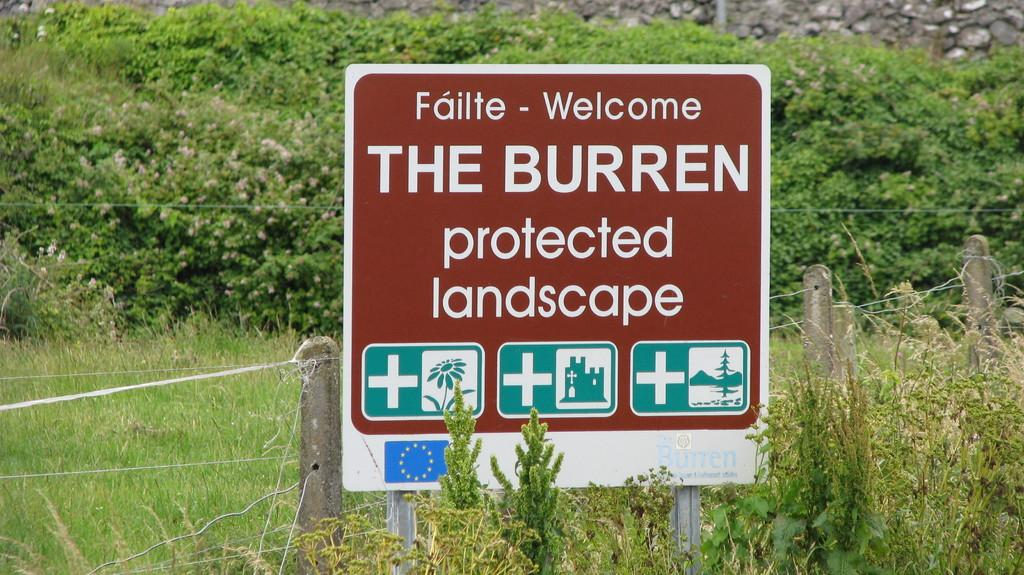<image>
Summarize the visual content of the image. A brown sign tells people that the landscape is protected. 